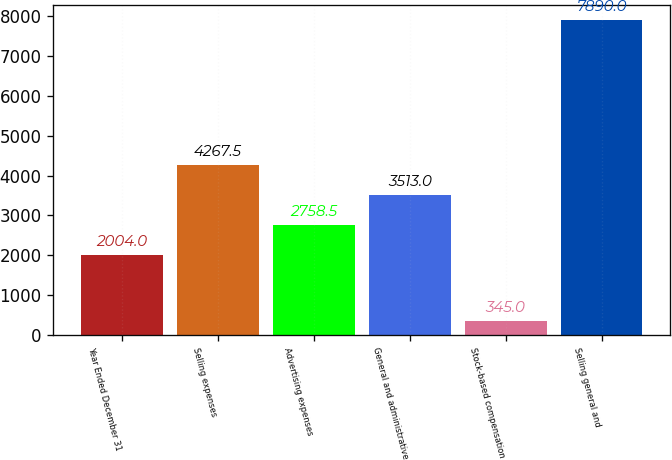Convert chart to OTSL. <chart><loc_0><loc_0><loc_500><loc_500><bar_chart><fcel>Year Ended December 31<fcel>Selling expenses<fcel>Advertising expenses<fcel>General and administrative<fcel>Stock-based compensation<fcel>Selling general and<nl><fcel>2004<fcel>4267.5<fcel>2758.5<fcel>3513<fcel>345<fcel>7890<nl></chart> 